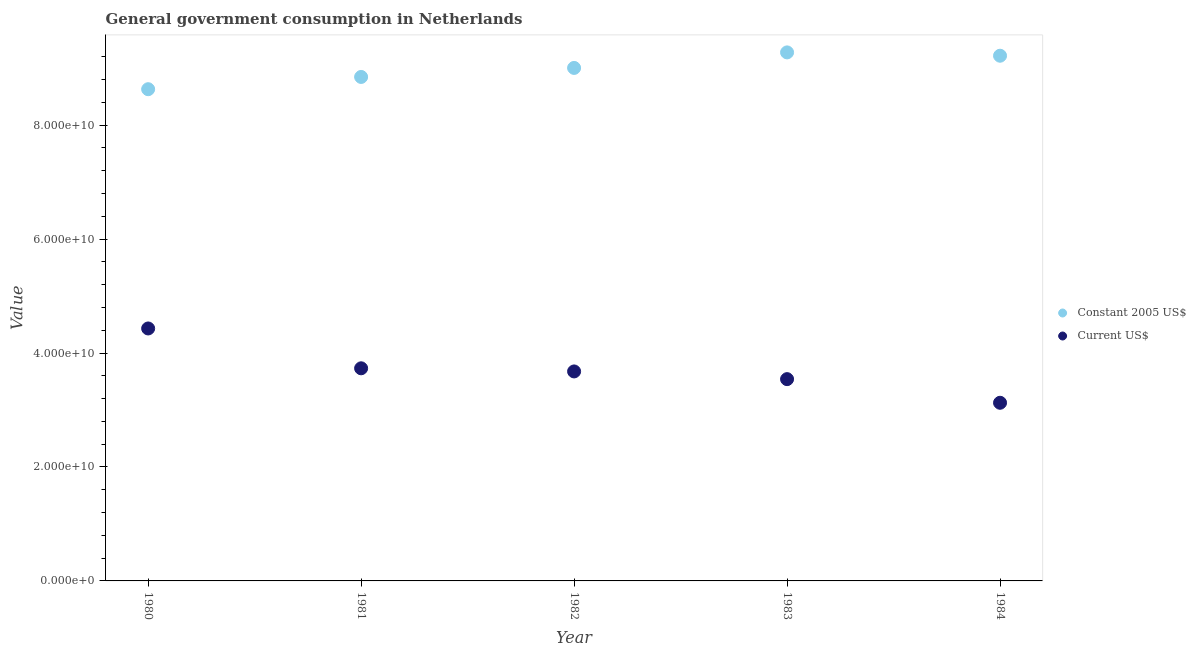Is the number of dotlines equal to the number of legend labels?
Your response must be concise. Yes. What is the value consumed in constant 2005 us$ in 1981?
Give a very brief answer. 8.84e+1. Across all years, what is the maximum value consumed in constant 2005 us$?
Your response must be concise. 9.28e+1. Across all years, what is the minimum value consumed in current us$?
Your answer should be very brief. 3.13e+1. In which year was the value consumed in current us$ maximum?
Keep it short and to the point. 1980. What is the total value consumed in current us$ in the graph?
Keep it short and to the point. 1.85e+11. What is the difference between the value consumed in constant 2005 us$ in 1983 and that in 1984?
Ensure brevity in your answer.  5.85e+08. What is the difference between the value consumed in constant 2005 us$ in 1982 and the value consumed in current us$ in 1980?
Give a very brief answer. 4.57e+1. What is the average value consumed in constant 2005 us$ per year?
Ensure brevity in your answer.  8.99e+1. In the year 1982, what is the difference between the value consumed in current us$ and value consumed in constant 2005 us$?
Offer a very short reply. -5.33e+1. In how many years, is the value consumed in current us$ greater than 40000000000?
Your answer should be very brief. 1. What is the ratio of the value consumed in constant 2005 us$ in 1980 to that in 1984?
Offer a terse response. 0.94. What is the difference between the highest and the second highest value consumed in constant 2005 us$?
Your answer should be very brief. 5.85e+08. What is the difference between the highest and the lowest value consumed in constant 2005 us$?
Provide a short and direct response. 6.46e+09. In how many years, is the value consumed in current us$ greater than the average value consumed in current us$ taken over all years?
Make the answer very short. 2. Does the value consumed in current us$ monotonically increase over the years?
Make the answer very short. No. Is the value consumed in constant 2005 us$ strictly greater than the value consumed in current us$ over the years?
Your answer should be very brief. Yes. Is the value consumed in current us$ strictly less than the value consumed in constant 2005 us$ over the years?
Provide a short and direct response. Yes. How many dotlines are there?
Your answer should be compact. 2. How many years are there in the graph?
Give a very brief answer. 5. Where does the legend appear in the graph?
Offer a very short reply. Center right. How many legend labels are there?
Ensure brevity in your answer.  2. How are the legend labels stacked?
Keep it short and to the point. Vertical. What is the title of the graph?
Your answer should be compact. General government consumption in Netherlands. What is the label or title of the Y-axis?
Your answer should be compact. Value. What is the Value in Constant 2005 US$ in 1980?
Provide a short and direct response. 8.63e+1. What is the Value in Current US$ in 1980?
Make the answer very short. 4.43e+1. What is the Value in Constant 2005 US$ in 1981?
Make the answer very short. 8.84e+1. What is the Value in Current US$ in 1981?
Provide a short and direct response. 3.73e+1. What is the Value of Constant 2005 US$ in 1982?
Offer a terse response. 9.00e+1. What is the Value in Current US$ in 1982?
Keep it short and to the point. 3.68e+1. What is the Value of Constant 2005 US$ in 1983?
Offer a terse response. 9.28e+1. What is the Value in Current US$ in 1983?
Provide a short and direct response. 3.54e+1. What is the Value in Constant 2005 US$ in 1984?
Provide a succinct answer. 9.22e+1. What is the Value in Current US$ in 1984?
Keep it short and to the point. 3.13e+1. Across all years, what is the maximum Value of Constant 2005 US$?
Offer a terse response. 9.28e+1. Across all years, what is the maximum Value of Current US$?
Ensure brevity in your answer.  4.43e+1. Across all years, what is the minimum Value of Constant 2005 US$?
Your answer should be very brief. 8.63e+1. Across all years, what is the minimum Value in Current US$?
Make the answer very short. 3.13e+1. What is the total Value of Constant 2005 US$ in the graph?
Ensure brevity in your answer.  4.50e+11. What is the total Value in Current US$ in the graph?
Your answer should be compact. 1.85e+11. What is the difference between the Value of Constant 2005 US$ in 1980 and that in 1981?
Make the answer very short. -2.15e+09. What is the difference between the Value of Current US$ in 1980 and that in 1981?
Offer a very short reply. 6.99e+09. What is the difference between the Value of Constant 2005 US$ in 1980 and that in 1982?
Keep it short and to the point. -3.73e+09. What is the difference between the Value in Current US$ in 1980 and that in 1982?
Provide a short and direct response. 7.54e+09. What is the difference between the Value of Constant 2005 US$ in 1980 and that in 1983?
Your response must be concise. -6.46e+09. What is the difference between the Value in Current US$ in 1980 and that in 1983?
Keep it short and to the point. 8.89e+09. What is the difference between the Value in Constant 2005 US$ in 1980 and that in 1984?
Give a very brief answer. -5.87e+09. What is the difference between the Value in Current US$ in 1980 and that in 1984?
Ensure brevity in your answer.  1.30e+1. What is the difference between the Value in Constant 2005 US$ in 1981 and that in 1982?
Provide a short and direct response. -1.58e+09. What is the difference between the Value of Current US$ in 1981 and that in 1982?
Your answer should be very brief. 5.50e+08. What is the difference between the Value in Constant 2005 US$ in 1981 and that in 1983?
Make the answer very short. -4.31e+09. What is the difference between the Value in Current US$ in 1981 and that in 1983?
Your answer should be compact. 1.90e+09. What is the difference between the Value of Constant 2005 US$ in 1981 and that in 1984?
Ensure brevity in your answer.  -3.72e+09. What is the difference between the Value of Current US$ in 1981 and that in 1984?
Your answer should be compact. 6.05e+09. What is the difference between the Value in Constant 2005 US$ in 1982 and that in 1983?
Provide a succinct answer. -2.73e+09. What is the difference between the Value in Current US$ in 1982 and that in 1983?
Provide a succinct answer. 1.35e+09. What is the difference between the Value in Constant 2005 US$ in 1982 and that in 1984?
Give a very brief answer. -2.14e+09. What is the difference between the Value in Current US$ in 1982 and that in 1984?
Offer a very short reply. 5.50e+09. What is the difference between the Value in Constant 2005 US$ in 1983 and that in 1984?
Keep it short and to the point. 5.85e+08. What is the difference between the Value of Current US$ in 1983 and that in 1984?
Give a very brief answer. 4.15e+09. What is the difference between the Value in Constant 2005 US$ in 1980 and the Value in Current US$ in 1981?
Your answer should be compact. 4.90e+1. What is the difference between the Value of Constant 2005 US$ in 1980 and the Value of Current US$ in 1982?
Keep it short and to the point. 4.95e+1. What is the difference between the Value of Constant 2005 US$ in 1980 and the Value of Current US$ in 1983?
Offer a terse response. 5.09e+1. What is the difference between the Value in Constant 2005 US$ in 1980 and the Value in Current US$ in 1984?
Your response must be concise. 5.50e+1. What is the difference between the Value of Constant 2005 US$ in 1981 and the Value of Current US$ in 1982?
Your response must be concise. 5.17e+1. What is the difference between the Value of Constant 2005 US$ in 1981 and the Value of Current US$ in 1983?
Ensure brevity in your answer.  5.30e+1. What is the difference between the Value in Constant 2005 US$ in 1981 and the Value in Current US$ in 1984?
Give a very brief answer. 5.72e+1. What is the difference between the Value of Constant 2005 US$ in 1982 and the Value of Current US$ in 1983?
Your answer should be compact. 5.46e+1. What is the difference between the Value in Constant 2005 US$ in 1982 and the Value in Current US$ in 1984?
Offer a terse response. 5.88e+1. What is the difference between the Value of Constant 2005 US$ in 1983 and the Value of Current US$ in 1984?
Provide a succinct answer. 6.15e+1. What is the average Value of Constant 2005 US$ per year?
Your response must be concise. 8.99e+1. What is the average Value in Current US$ per year?
Your answer should be very brief. 3.70e+1. In the year 1980, what is the difference between the Value in Constant 2005 US$ and Value in Current US$?
Give a very brief answer. 4.20e+1. In the year 1981, what is the difference between the Value in Constant 2005 US$ and Value in Current US$?
Offer a terse response. 5.11e+1. In the year 1982, what is the difference between the Value in Constant 2005 US$ and Value in Current US$?
Your answer should be compact. 5.33e+1. In the year 1983, what is the difference between the Value in Constant 2005 US$ and Value in Current US$?
Offer a terse response. 5.73e+1. In the year 1984, what is the difference between the Value in Constant 2005 US$ and Value in Current US$?
Offer a terse response. 6.09e+1. What is the ratio of the Value in Constant 2005 US$ in 1980 to that in 1981?
Your answer should be compact. 0.98. What is the ratio of the Value in Current US$ in 1980 to that in 1981?
Provide a short and direct response. 1.19. What is the ratio of the Value in Constant 2005 US$ in 1980 to that in 1982?
Your answer should be very brief. 0.96. What is the ratio of the Value in Current US$ in 1980 to that in 1982?
Provide a short and direct response. 1.21. What is the ratio of the Value of Constant 2005 US$ in 1980 to that in 1983?
Provide a short and direct response. 0.93. What is the ratio of the Value of Current US$ in 1980 to that in 1983?
Offer a terse response. 1.25. What is the ratio of the Value of Constant 2005 US$ in 1980 to that in 1984?
Your answer should be very brief. 0.94. What is the ratio of the Value of Current US$ in 1980 to that in 1984?
Give a very brief answer. 1.42. What is the ratio of the Value of Constant 2005 US$ in 1981 to that in 1982?
Give a very brief answer. 0.98. What is the ratio of the Value in Constant 2005 US$ in 1981 to that in 1983?
Provide a succinct answer. 0.95. What is the ratio of the Value of Current US$ in 1981 to that in 1983?
Make the answer very short. 1.05. What is the ratio of the Value of Constant 2005 US$ in 1981 to that in 1984?
Give a very brief answer. 0.96. What is the ratio of the Value of Current US$ in 1981 to that in 1984?
Offer a very short reply. 1.19. What is the ratio of the Value in Constant 2005 US$ in 1982 to that in 1983?
Offer a terse response. 0.97. What is the ratio of the Value of Current US$ in 1982 to that in 1983?
Offer a very short reply. 1.04. What is the ratio of the Value in Constant 2005 US$ in 1982 to that in 1984?
Ensure brevity in your answer.  0.98. What is the ratio of the Value in Current US$ in 1982 to that in 1984?
Your answer should be compact. 1.18. What is the ratio of the Value in Constant 2005 US$ in 1983 to that in 1984?
Your answer should be compact. 1.01. What is the ratio of the Value in Current US$ in 1983 to that in 1984?
Make the answer very short. 1.13. What is the difference between the highest and the second highest Value of Constant 2005 US$?
Ensure brevity in your answer.  5.85e+08. What is the difference between the highest and the second highest Value of Current US$?
Give a very brief answer. 6.99e+09. What is the difference between the highest and the lowest Value in Constant 2005 US$?
Ensure brevity in your answer.  6.46e+09. What is the difference between the highest and the lowest Value of Current US$?
Your answer should be very brief. 1.30e+1. 